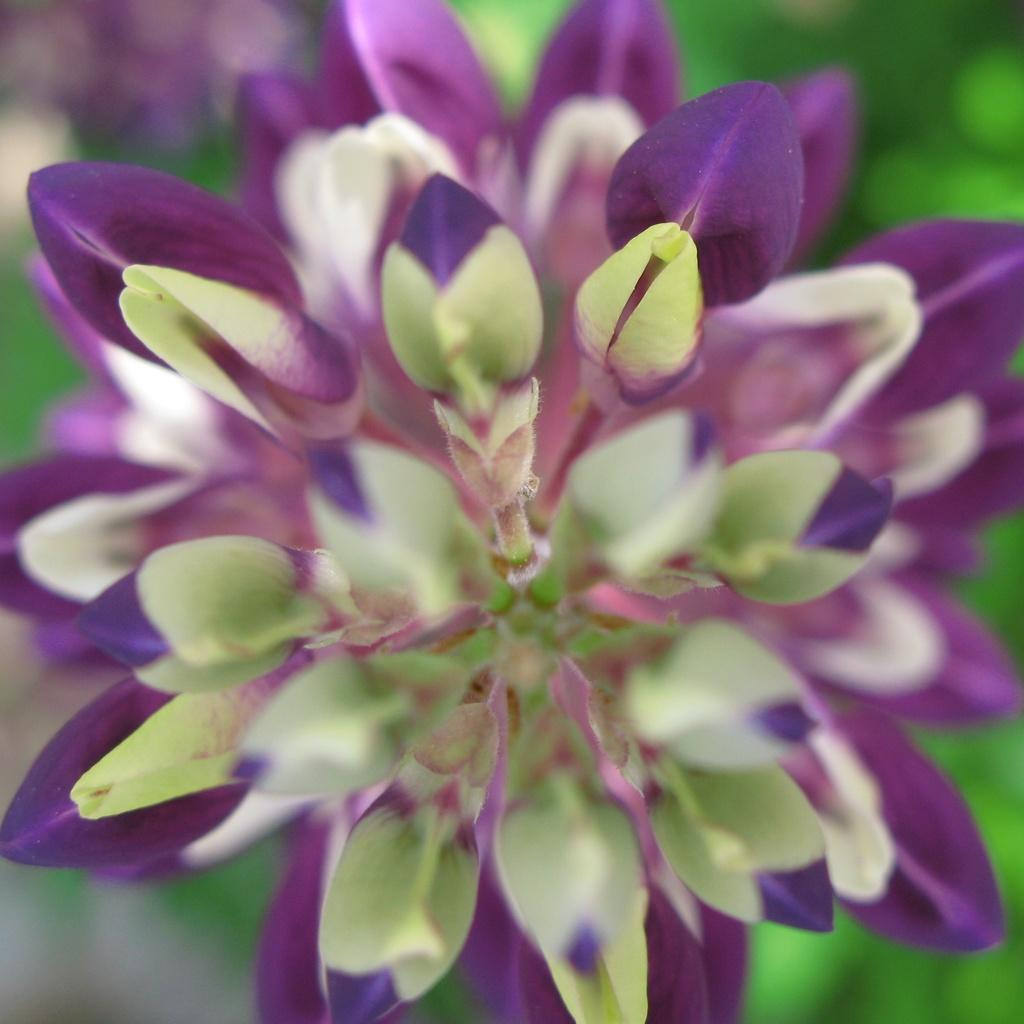What is the main subject of the image? There is a flower in the image. What can be observed about the metal objects in the image? The metal objects have violet and light green colors. How would you describe the background of the image? The background of the image appears blurry. What type of mask is being worn by the flower in the image? There is no mask present in the image, as it features a flower and metal objects with no people or faces. 